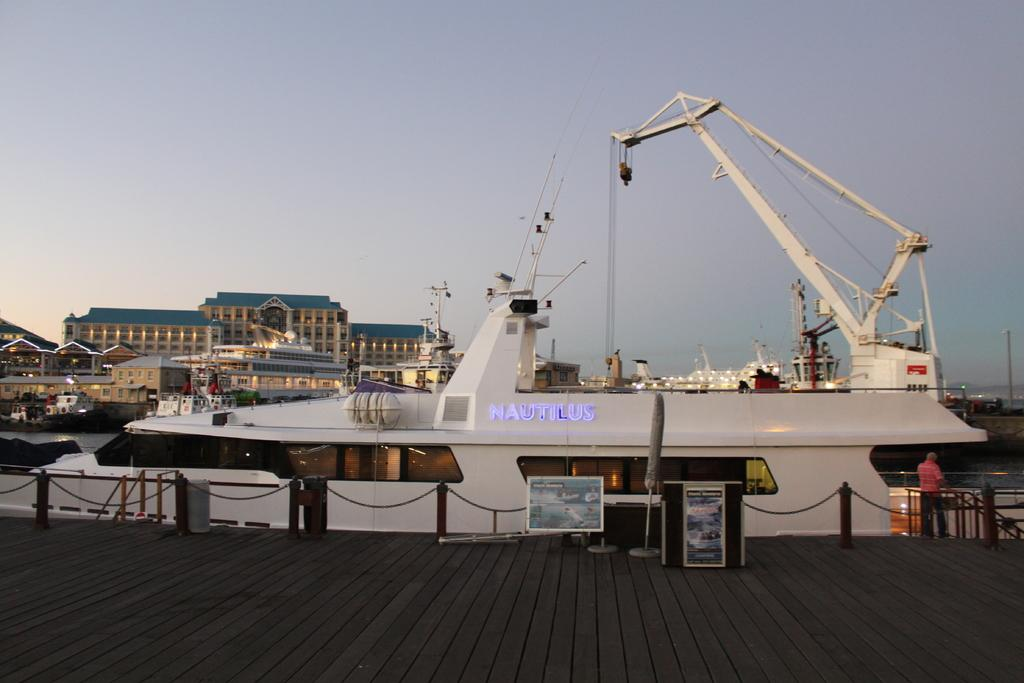What type of surface is visible in the image? There is a wooden patio in the image. What is present to provide a boundary or enclosure in the image? There is fencing in the image. What can be seen in the distance in the image? Ships and buildings are visible in the background of the image. How would you describe the weather based on the image? The sky is cloudy in the background of the image, suggesting a potentially overcast or cloudy day. What type of insurance policy is being discussed by the people on the wooden patio in the image? There are no people present in the image, and therefore no discussion about insurance policies can be observed. 